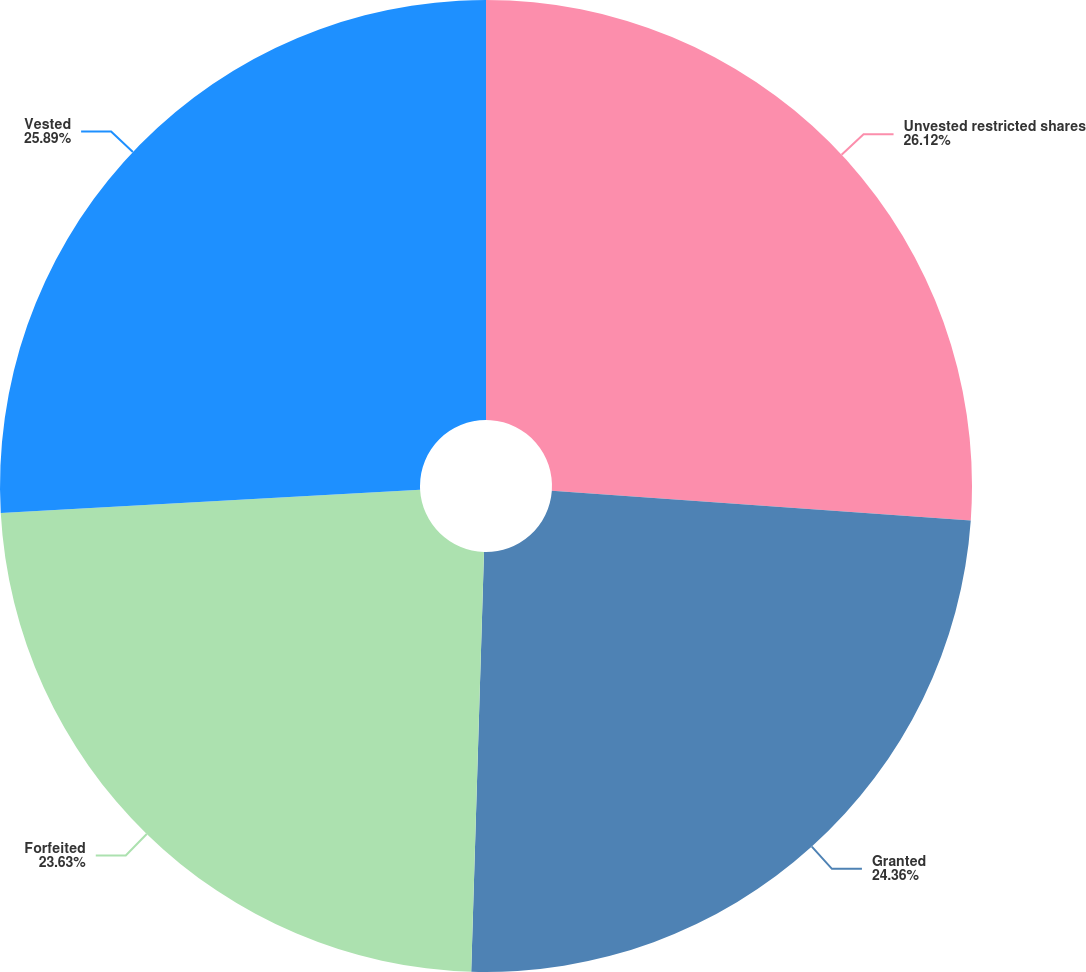Convert chart to OTSL. <chart><loc_0><loc_0><loc_500><loc_500><pie_chart><fcel>Unvested restricted shares<fcel>Granted<fcel>Forfeited<fcel>Vested<nl><fcel>26.13%<fcel>24.36%<fcel>23.63%<fcel>25.89%<nl></chart> 